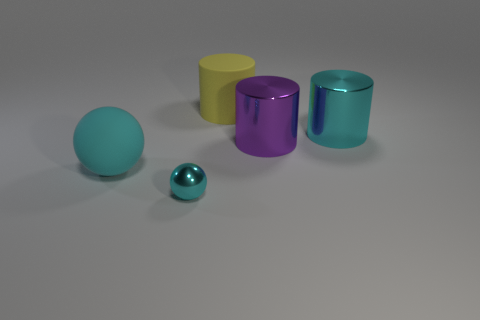What number of objects are big matte things in front of the cyan metal cylinder or big cyan things that are right of the large yellow rubber object?
Your response must be concise. 2. Does the cylinder that is in front of the big cyan metallic cylinder have the same size as the rubber object that is right of the large sphere?
Offer a very short reply. Yes. There is another thing that is the same shape as the small cyan metallic thing; what color is it?
Provide a succinct answer. Cyan. Is there anything else that is the same shape as the yellow matte object?
Give a very brief answer. Yes. Are there more tiny cyan things behind the tiny sphere than cyan metal cylinders that are behind the cyan rubber sphere?
Provide a short and direct response. No. There is a cylinder that is behind the big cyan object that is on the right side of the large matte object behind the large cyan matte ball; what size is it?
Make the answer very short. Large. Does the cyan cylinder have the same material as the cyan ball that is behind the small metallic thing?
Provide a succinct answer. No. Is the large cyan matte thing the same shape as the big purple shiny thing?
Offer a very short reply. No. How many other objects are the same material as the big purple cylinder?
Your response must be concise. 2. How many big matte things are the same shape as the small cyan metal object?
Give a very brief answer. 1. 